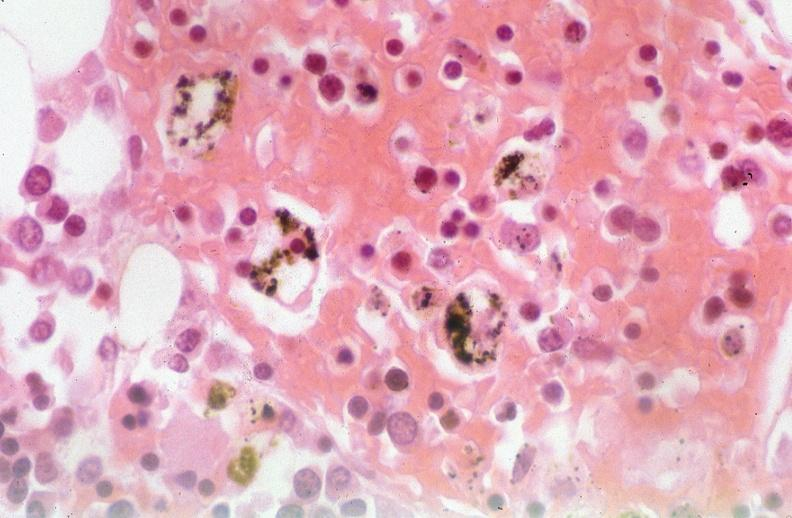what does this image show?
Answer the question using a single word or phrase. Pleura 